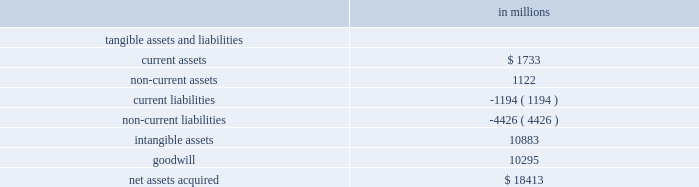Visa inc .
Notes to consolidated financial statements 2014 ( continued ) september 30 , 2009 ( in millions , except as noted ) to value the shares issued on june 15 , 2007 ( the 201cmeasurement date 201d ) , the company primarily relied upon the analysis of comparable companies with similar industry , business model and financial profiles .
This analysis considered a range of metrics including the forward multiples of revenue ; earnings before interest , depreciation and amortization ; and net income of these comparable companies .
Ultimately , the company determined that the forward net income multiple was the most appropriate measure to value the acquired regions and reflect anticipated changes in the company 2019s financial profile prospectively .
This multiple was applied to the corresponding forward net income of the acquired regions to calculate their value .
The most comparable company identified was mastercard inc .
Therefore , the most significant input into this analysis was mastercard 2019s forward net income multiple of 27 times net income at the measurement date .
Visa inc .
Common stock issued to visa europe as part of the reorganization , visa europe received 62762788 shares of class c ( series iii and iv ) common stock valued at $ 3.1 billion based on the value of the class c ( series i ) common stock issued to the acquired regions .
Visa europe also received 27904464 shares of class c ( series ii ) common stock valued at $ 1.104 billion determined by discounting the redemption price of these shares using a risk-free rate of 4.9% ( 4.9 % ) over the period to october 2008 , when these shares were redeemed by the company .
Prior to the ipo , the company issued visa europe an additional 51844393 class c ( series ii ) common stock at a price of $ 44 per share in exchange for a subscription receivable .
The issuance and subscription receivable were recorded as offsetting entries in temporary equity at september 30 , 2008 .
Completion of the company 2019s ipo triggered the redemption feature of this stock and in march 2008 , the company reclassified all outstanding shares of the class c ( series ii ) common stock at its then fair value of $ 1.125 billion to temporary equity on the consolidated balance sheet with a corresponding reduction in additional paid-in-capital of $ 1.104 billion and accumulated income of $ 21 million .
From march 2008 to october 10 , 2008 , the date these shares were redeemed , the company recorded accretion of this stock to its redemption price through accumulated income .
Fair value of assets acquired and liabilities assumed total purchase consideration has been allocated to the tangible and identifiable intangible assets and liabilities assumed underlying the acquired interests based on their fair value on the reorganization date .
The excess of purchase consideration over net assets assumed was recorded as goodwill .
The table summarizes this allocation. .

What is the total net assets of the company? 
Computations: (18413 - 10295)
Answer: 8118.0. 